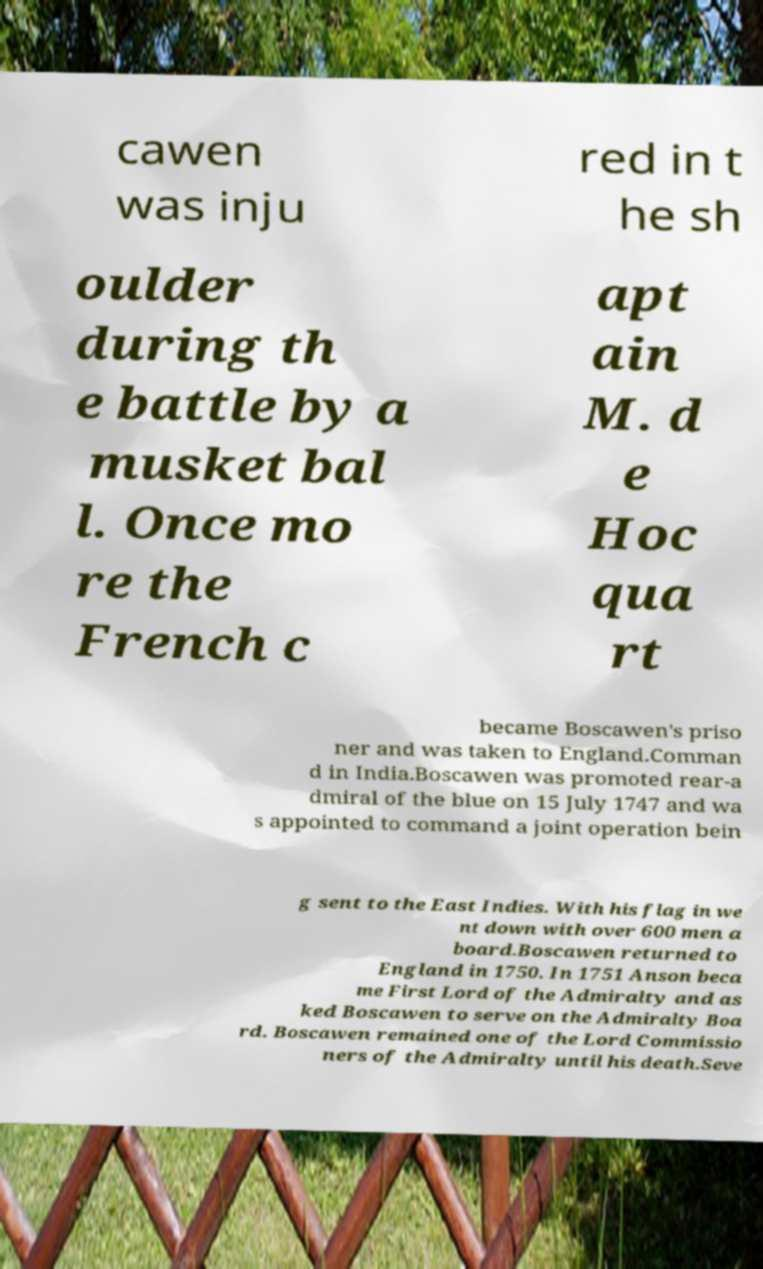I need the written content from this picture converted into text. Can you do that? cawen was inju red in t he sh oulder during th e battle by a musket bal l. Once mo re the French c apt ain M. d e Hoc qua rt became Boscawen's priso ner and was taken to England.Comman d in India.Boscawen was promoted rear-a dmiral of the blue on 15 July 1747 and wa s appointed to command a joint operation bein g sent to the East Indies. With his flag in we nt down with over 600 men a board.Boscawen returned to England in 1750. In 1751 Anson beca me First Lord of the Admiralty and as ked Boscawen to serve on the Admiralty Boa rd. Boscawen remained one of the Lord Commissio ners of the Admiralty until his death.Seve 